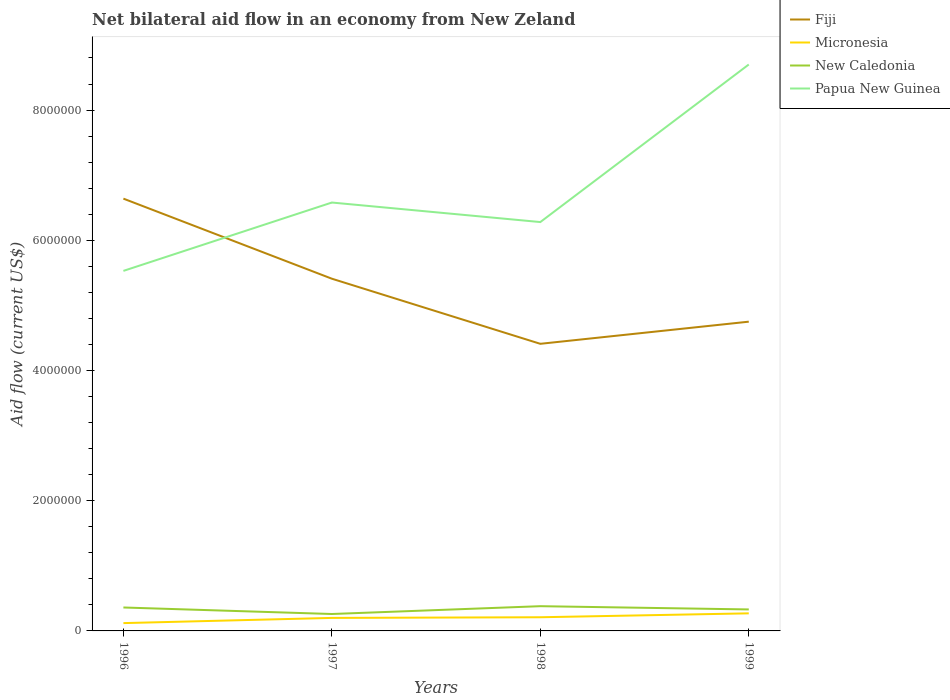Is the number of lines equal to the number of legend labels?
Provide a succinct answer. Yes. Across all years, what is the maximum net bilateral aid flow in Papua New Guinea?
Make the answer very short. 5.53e+06. What is the total net bilateral aid flow in Papua New Guinea in the graph?
Offer a terse response. -1.05e+06. What is the difference between the highest and the second highest net bilateral aid flow in New Caledonia?
Keep it short and to the point. 1.20e+05. Is the net bilateral aid flow in Papua New Guinea strictly greater than the net bilateral aid flow in Fiji over the years?
Provide a succinct answer. No. How many lines are there?
Give a very brief answer. 4. How many years are there in the graph?
Offer a very short reply. 4. Does the graph contain any zero values?
Provide a succinct answer. No. Does the graph contain grids?
Ensure brevity in your answer.  No. What is the title of the graph?
Your answer should be very brief. Net bilateral aid flow in an economy from New Zeland. Does "Ecuador" appear as one of the legend labels in the graph?
Your response must be concise. No. What is the label or title of the X-axis?
Provide a short and direct response. Years. What is the Aid flow (current US$) of Fiji in 1996?
Provide a succinct answer. 6.64e+06. What is the Aid flow (current US$) in Micronesia in 1996?
Offer a terse response. 1.20e+05. What is the Aid flow (current US$) of Papua New Guinea in 1996?
Your answer should be compact. 5.53e+06. What is the Aid flow (current US$) in Fiji in 1997?
Offer a very short reply. 5.41e+06. What is the Aid flow (current US$) in Micronesia in 1997?
Offer a very short reply. 2.00e+05. What is the Aid flow (current US$) of Papua New Guinea in 1997?
Provide a short and direct response. 6.58e+06. What is the Aid flow (current US$) of Fiji in 1998?
Keep it short and to the point. 4.41e+06. What is the Aid flow (current US$) in Micronesia in 1998?
Ensure brevity in your answer.  2.10e+05. What is the Aid flow (current US$) of New Caledonia in 1998?
Ensure brevity in your answer.  3.80e+05. What is the Aid flow (current US$) in Papua New Guinea in 1998?
Your answer should be very brief. 6.28e+06. What is the Aid flow (current US$) in Fiji in 1999?
Offer a terse response. 4.75e+06. What is the Aid flow (current US$) of Micronesia in 1999?
Your response must be concise. 2.70e+05. What is the Aid flow (current US$) of Papua New Guinea in 1999?
Your answer should be very brief. 8.70e+06. Across all years, what is the maximum Aid flow (current US$) in Fiji?
Provide a short and direct response. 6.64e+06. Across all years, what is the maximum Aid flow (current US$) in Papua New Guinea?
Provide a succinct answer. 8.70e+06. Across all years, what is the minimum Aid flow (current US$) in Fiji?
Offer a very short reply. 4.41e+06. Across all years, what is the minimum Aid flow (current US$) in Papua New Guinea?
Make the answer very short. 5.53e+06. What is the total Aid flow (current US$) of Fiji in the graph?
Your response must be concise. 2.12e+07. What is the total Aid flow (current US$) in New Caledonia in the graph?
Provide a short and direct response. 1.33e+06. What is the total Aid flow (current US$) of Papua New Guinea in the graph?
Provide a short and direct response. 2.71e+07. What is the difference between the Aid flow (current US$) in Fiji in 1996 and that in 1997?
Give a very brief answer. 1.23e+06. What is the difference between the Aid flow (current US$) in Papua New Guinea in 1996 and that in 1997?
Offer a very short reply. -1.05e+06. What is the difference between the Aid flow (current US$) in Fiji in 1996 and that in 1998?
Your answer should be compact. 2.23e+06. What is the difference between the Aid flow (current US$) in New Caledonia in 1996 and that in 1998?
Your response must be concise. -2.00e+04. What is the difference between the Aid flow (current US$) of Papua New Guinea in 1996 and that in 1998?
Offer a very short reply. -7.50e+05. What is the difference between the Aid flow (current US$) in Fiji in 1996 and that in 1999?
Your answer should be compact. 1.89e+06. What is the difference between the Aid flow (current US$) of Micronesia in 1996 and that in 1999?
Provide a succinct answer. -1.50e+05. What is the difference between the Aid flow (current US$) in New Caledonia in 1996 and that in 1999?
Provide a short and direct response. 3.00e+04. What is the difference between the Aid flow (current US$) of Papua New Guinea in 1996 and that in 1999?
Offer a terse response. -3.17e+06. What is the difference between the Aid flow (current US$) in Papua New Guinea in 1997 and that in 1998?
Make the answer very short. 3.00e+05. What is the difference between the Aid flow (current US$) in Fiji in 1997 and that in 1999?
Your answer should be very brief. 6.60e+05. What is the difference between the Aid flow (current US$) in Micronesia in 1997 and that in 1999?
Offer a very short reply. -7.00e+04. What is the difference between the Aid flow (current US$) in New Caledonia in 1997 and that in 1999?
Provide a succinct answer. -7.00e+04. What is the difference between the Aid flow (current US$) in Papua New Guinea in 1997 and that in 1999?
Offer a terse response. -2.12e+06. What is the difference between the Aid flow (current US$) of Fiji in 1998 and that in 1999?
Your answer should be very brief. -3.40e+05. What is the difference between the Aid flow (current US$) in Papua New Guinea in 1998 and that in 1999?
Make the answer very short. -2.42e+06. What is the difference between the Aid flow (current US$) of Fiji in 1996 and the Aid flow (current US$) of Micronesia in 1997?
Your response must be concise. 6.44e+06. What is the difference between the Aid flow (current US$) of Fiji in 1996 and the Aid flow (current US$) of New Caledonia in 1997?
Your response must be concise. 6.38e+06. What is the difference between the Aid flow (current US$) of Fiji in 1996 and the Aid flow (current US$) of Papua New Guinea in 1997?
Offer a very short reply. 6.00e+04. What is the difference between the Aid flow (current US$) in Micronesia in 1996 and the Aid flow (current US$) in New Caledonia in 1997?
Your answer should be compact. -1.40e+05. What is the difference between the Aid flow (current US$) of Micronesia in 1996 and the Aid flow (current US$) of Papua New Guinea in 1997?
Your answer should be compact. -6.46e+06. What is the difference between the Aid flow (current US$) in New Caledonia in 1996 and the Aid flow (current US$) in Papua New Guinea in 1997?
Give a very brief answer. -6.22e+06. What is the difference between the Aid flow (current US$) of Fiji in 1996 and the Aid flow (current US$) of Micronesia in 1998?
Make the answer very short. 6.43e+06. What is the difference between the Aid flow (current US$) of Fiji in 1996 and the Aid flow (current US$) of New Caledonia in 1998?
Ensure brevity in your answer.  6.26e+06. What is the difference between the Aid flow (current US$) in Fiji in 1996 and the Aid flow (current US$) in Papua New Guinea in 1998?
Keep it short and to the point. 3.60e+05. What is the difference between the Aid flow (current US$) in Micronesia in 1996 and the Aid flow (current US$) in Papua New Guinea in 1998?
Ensure brevity in your answer.  -6.16e+06. What is the difference between the Aid flow (current US$) in New Caledonia in 1996 and the Aid flow (current US$) in Papua New Guinea in 1998?
Offer a terse response. -5.92e+06. What is the difference between the Aid flow (current US$) of Fiji in 1996 and the Aid flow (current US$) of Micronesia in 1999?
Give a very brief answer. 6.37e+06. What is the difference between the Aid flow (current US$) in Fiji in 1996 and the Aid flow (current US$) in New Caledonia in 1999?
Your response must be concise. 6.31e+06. What is the difference between the Aid flow (current US$) in Fiji in 1996 and the Aid flow (current US$) in Papua New Guinea in 1999?
Your answer should be very brief. -2.06e+06. What is the difference between the Aid flow (current US$) in Micronesia in 1996 and the Aid flow (current US$) in New Caledonia in 1999?
Your answer should be very brief. -2.10e+05. What is the difference between the Aid flow (current US$) in Micronesia in 1996 and the Aid flow (current US$) in Papua New Guinea in 1999?
Provide a succinct answer. -8.58e+06. What is the difference between the Aid flow (current US$) of New Caledonia in 1996 and the Aid flow (current US$) of Papua New Guinea in 1999?
Your answer should be very brief. -8.34e+06. What is the difference between the Aid flow (current US$) of Fiji in 1997 and the Aid flow (current US$) of Micronesia in 1998?
Provide a short and direct response. 5.20e+06. What is the difference between the Aid flow (current US$) in Fiji in 1997 and the Aid flow (current US$) in New Caledonia in 1998?
Offer a very short reply. 5.03e+06. What is the difference between the Aid flow (current US$) in Fiji in 1997 and the Aid flow (current US$) in Papua New Guinea in 1998?
Ensure brevity in your answer.  -8.70e+05. What is the difference between the Aid flow (current US$) in Micronesia in 1997 and the Aid flow (current US$) in New Caledonia in 1998?
Your response must be concise. -1.80e+05. What is the difference between the Aid flow (current US$) in Micronesia in 1997 and the Aid flow (current US$) in Papua New Guinea in 1998?
Your answer should be very brief. -6.08e+06. What is the difference between the Aid flow (current US$) of New Caledonia in 1997 and the Aid flow (current US$) of Papua New Guinea in 1998?
Your answer should be compact. -6.02e+06. What is the difference between the Aid flow (current US$) in Fiji in 1997 and the Aid flow (current US$) in Micronesia in 1999?
Make the answer very short. 5.14e+06. What is the difference between the Aid flow (current US$) in Fiji in 1997 and the Aid flow (current US$) in New Caledonia in 1999?
Keep it short and to the point. 5.08e+06. What is the difference between the Aid flow (current US$) in Fiji in 1997 and the Aid flow (current US$) in Papua New Guinea in 1999?
Ensure brevity in your answer.  -3.29e+06. What is the difference between the Aid flow (current US$) in Micronesia in 1997 and the Aid flow (current US$) in Papua New Guinea in 1999?
Ensure brevity in your answer.  -8.50e+06. What is the difference between the Aid flow (current US$) in New Caledonia in 1997 and the Aid flow (current US$) in Papua New Guinea in 1999?
Offer a terse response. -8.44e+06. What is the difference between the Aid flow (current US$) of Fiji in 1998 and the Aid flow (current US$) of Micronesia in 1999?
Provide a short and direct response. 4.14e+06. What is the difference between the Aid flow (current US$) in Fiji in 1998 and the Aid flow (current US$) in New Caledonia in 1999?
Offer a very short reply. 4.08e+06. What is the difference between the Aid flow (current US$) in Fiji in 1998 and the Aid flow (current US$) in Papua New Guinea in 1999?
Your response must be concise. -4.29e+06. What is the difference between the Aid flow (current US$) of Micronesia in 1998 and the Aid flow (current US$) of Papua New Guinea in 1999?
Offer a terse response. -8.49e+06. What is the difference between the Aid flow (current US$) of New Caledonia in 1998 and the Aid flow (current US$) of Papua New Guinea in 1999?
Your answer should be compact. -8.32e+06. What is the average Aid flow (current US$) of Fiji per year?
Provide a succinct answer. 5.30e+06. What is the average Aid flow (current US$) in Micronesia per year?
Provide a short and direct response. 2.00e+05. What is the average Aid flow (current US$) of New Caledonia per year?
Provide a short and direct response. 3.32e+05. What is the average Aid flow (current US$) in Papua New Guinea per year?
Provide a short and direct response. 6.77e+06. In the year 1996, what is the difference between the Aid flow (current US$) of Fiji and Aid flow (current US$) of Micronesia?
Offer a terse response. 6.52e+06. In the year 1996, what is the difference between the Aid flow (current US$) of Fiji and Aid flow (current US$) of New Caledonia?
Make the answer very short. 6.28e+06. In the year 1996, what is the difference between the Aid flow (current US$) of Fiji and Aid flow (current US$) of Papua New Guinea?
Provide a succinct answer. 1.11e+06. In the year 1996, what is the difference between the Aid flow (current US$) in Micronesia and Aid flow (current US$) in Papua New Guinea?
Ensure brevity in your answer.  -5.41e+06. In the year 1996, what is the difference between the Aid flow (current US$) in New Caledonia and Aid flow (current US$) in Papua New Guinea?
Ensure brevity in your answer.  -5.17e+06. In the year 1997, what is the difference between the Aid flow (current US$) of Fiji and Aid flow (current US$) of Micronesia?
Provide a short and direct response. 5.21e+06. In the year 1997, what is the difference between the Aid flow (current US$) in Fiji and Aid flow (current US$) in New Caledonia?
Provide a succinct answer. 5.15e+06. In the year 1997, what is the difference between the Aid flow (current US$) of Fiji and Aid flow (current US$) of Papua New Guinea?
Keep it short and to the point. -1.17e+06. In the year 1997, what is the difference between the Aid flow (current US$) in Micronesia and Aid flow (current US$) in Papua New Guinea?
Provide a succinct answer. -6.38e+06. In the year 1997, what is the difference between the Aid flow (current US$) of New Caledonia and Aid flow (current US$) of Papua New Guinea?
Your answer should be very brief. -6.32e+06. In the year 1998, what is the difference between the Aid flow (current US$) of Fiji and Aid flow (current US$) of Micronesia?
Offer a very short reply. 4.20e+06. In the year 1998, what is the difference between the Aid flow (current US$) of Fiji and Aid flow (current US$) of New Caledonia?
Ensure brevity in your answer.  4.03e+06. In the year 1998, what is the difference between the Aid flow (current US$) of Fiji and Aid flow (current US$) of Papua New Guinea?
Your answer should be very brief. -1.87e+06. In the year 1998, what is the difference between the Aid flow (current US$) in Micronesia and Aid flow (current US$) in Papua New Guinea?
Your response must be concise. -6.07e+06. In the year 1998, what is the difference between the Aid flow (current US$) of New Caledonia and Aid flow (current US$) of Papua New Guinea?
Make the answer very short. -5.90e+06. In the year 1999, what is the difference between the Aid flow (current US$) in Fiji and Aid flow (current US$) in Micronesia?
Offer a very short reply. 4.48e+06. In the year 1999, what is the difference between the Aid flow (current US$) of Fiji and Aid flow (current US$) of New Caledonia?
Your answer should be very brief. 4.42e+06. In the year 1999, what is the difference between the Aid flow (current US$) in Fiji and Aid flow (current US$) in Papua New Guinea?
Give a very brief answer. -3.95e+06. In the year 1999, what is the difference between the Aid flow (current US$) in Micronesia and Aid flow (current US$) in Papua New Guinea?
Keep it short and to the point. -8.43e+06. In the year 1999, what is the difference between the Aid flow (current US$) in New Caledonia and Aid flow (current US$) in Papua New Guinea?
Your answer should be compact. -8.37e+06. What is the ratio of the Aid flow (current US$) in Fiji in 1996 to that in 1997?
Provide a succinct answer. 1.23. What is the ratio of the Aid flow (current US$) of New Caledonia in 1996 to that in 1997?
Your answer should be compact. 1.38. What is the ratio of the Aid flow (current US$) of Papua New Guinea in 1996 to that in 1997?
Ensure brevity in your answer.  0.84. What is the ratio of the Aid flow (current US$) of Fiji in 1996 to that in 1998?
Your answer should be compact. 1.51. What is the ratio of the Aid flow (current US$) in Micronesia in 1996 to that in 1998?
Provide a succinct answer. 0.57. What is the ratio of the Aid flow (current US$) in Papua New Guinea in 1996 to that in 1998?
Your response must be concise. 0.88. What is the ratio of the Aid flow (current US$) of Fiji in 1996 to that in 1999?
Your answer should be very brief. 1.4. What is the ratio of the Aid flow (current US$) of Micronesia in 1996 to that in 1999?
Ensure brevity in your answer.  0.44. What is the ratio of the Aid flow (current US$) of New Caledonia in 1996 to that in 1999?
Your answer should be compact. 1.09. What is the ratio of the Aid flow (current US$) of Papua New Guinea in 1996 to that in 1999?
Make the answer very short. 0.64. What is the ratio of the Aid flow (current US$) of Fiji in 1997 to that in 1998?
Keep it short and to the point. 1.23. What is the ratio of the Aid flow (current US$) of Micronesia in 1997 to that in 1998?
Your answer should be very brief. 0.95. What is the ratio of the Aid flow (current US$) of New Caledonia in 1997 to that in 1998?
Make the answer very short. 0.68. What is the ratio of the Aid flow (current US$) in Papua New Guinea in 1997 to that in 1998?
Provide a short and direct response. 1.05. What is the ratio of the Aid flow (current US$) of Fiji in 1997 to that in 1999?
Provide a short and direct response. 1.14. What is the ratio of the Aid flow (current US$) of Micronesia in 1997 to that in 1999?
Make the answer very short. 0.74. What is the ratio of the Aid flow (current US$) of New Caledonia in 1997 to that in 1999?
Your answer should be compact. 0.79. What is the ratio of the Aid flow (current US$) in Papua New Guinea in 1997 to that in 1999?
Your answer should be very brief. 0.76. What is the ratio of the Aid flow (current US$) in Fiji in 1998 to that in 1999?
Your answer should be compact. 0.93. What is the ratio of the Aid flow (current US$) of New Caledonia in 1998 to that in 1999?
Offer a very short reply. 1.15. What is the ratio of the Aid flow (current US$) in Papua New Guinea in 1998 to that in 1999?
Make the answer very short. 0.72. What is the difference between the highest and the second highest Aid flow (current US$) of Fiji?
Give a very brief answer. 1.23e+06. What is the difference between the highest and the second highest Aid flow (current US$) in Micronesia?
Give a very brief answer. 6.00e+04. What is the difference between the highest and the second highest Aid flow (current US$) in Papua New Guinea?
Ensure brevity in your answer.  2.12e+06. What is the difference between the highest and the lowest Aid flow (current US$) in Fiji?
Provide a succinct answer. 2.23e+06. What is the difference between the highest and the lowest Aid flow (current US$) in Micronesia?
Ensure brevity in your answer.  1.50e+05. What is the difference between the highest and the lowest Aid flow (current US$) in Papua New Guinea?
Your response must be concise. 3.17e+06. 